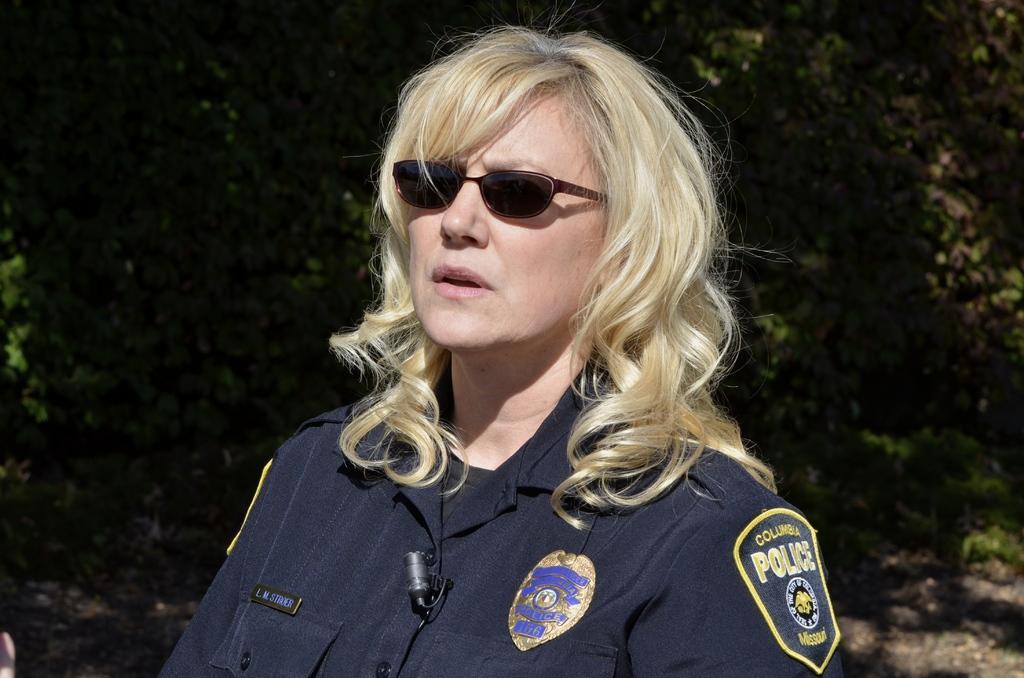How would you summarize this image in a sentence or two? In the center of the image a lady is wearing uniform and goggles. In the background of the image we can see the trees. At the bottom of the image we can see the ground. 